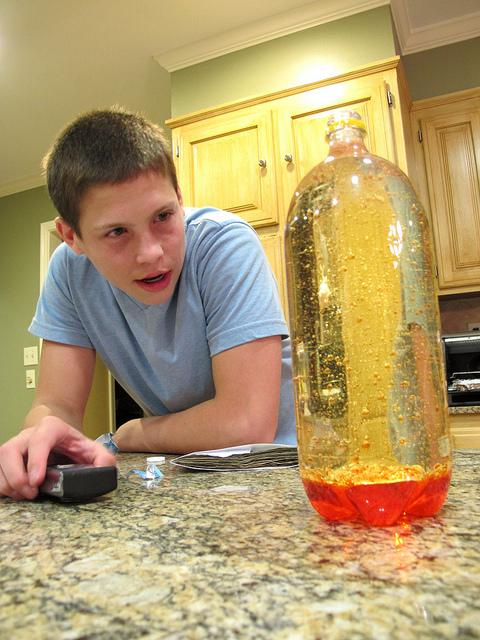What has the boy made using the bottle?

Choices:
A) bottle rocket
B) grape jelly
C) lava lamp
D) hand sanitizer lava lamp 